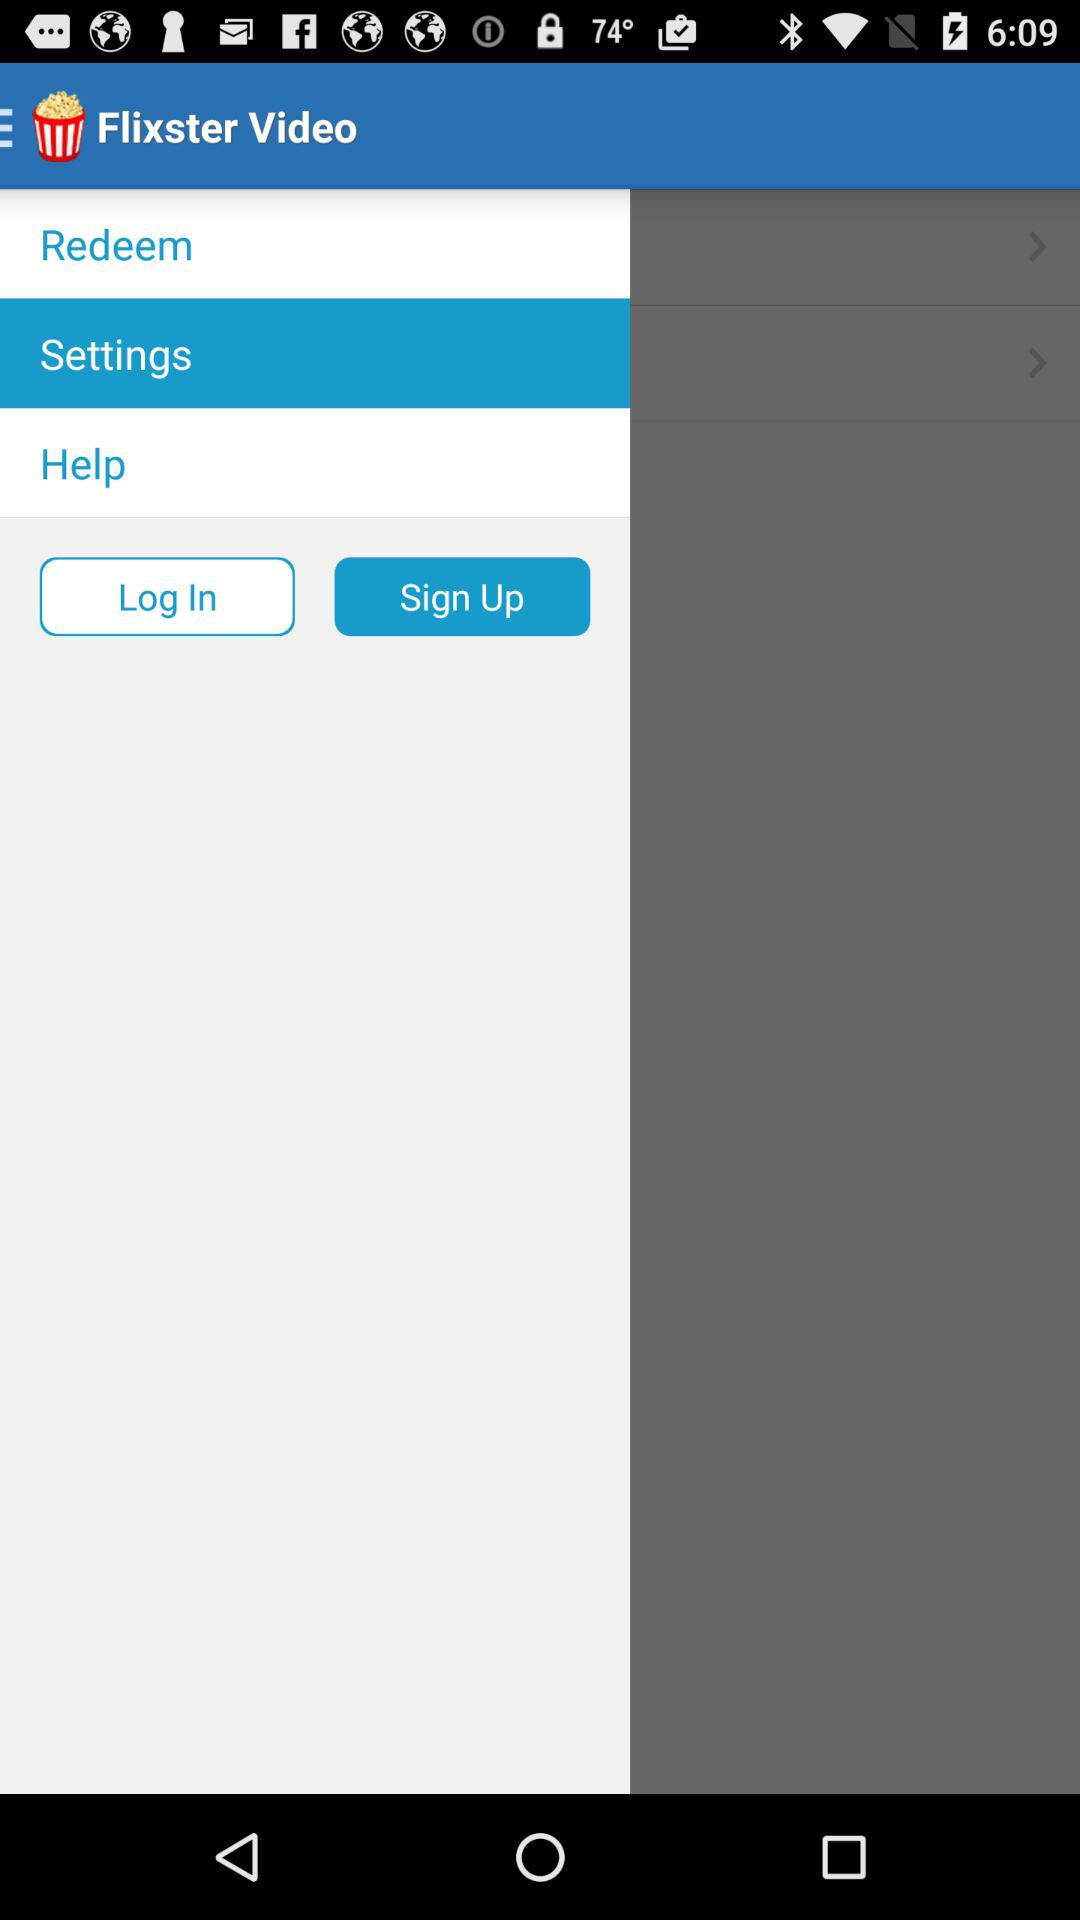What is the application name? The application name is "Flixster Video". 